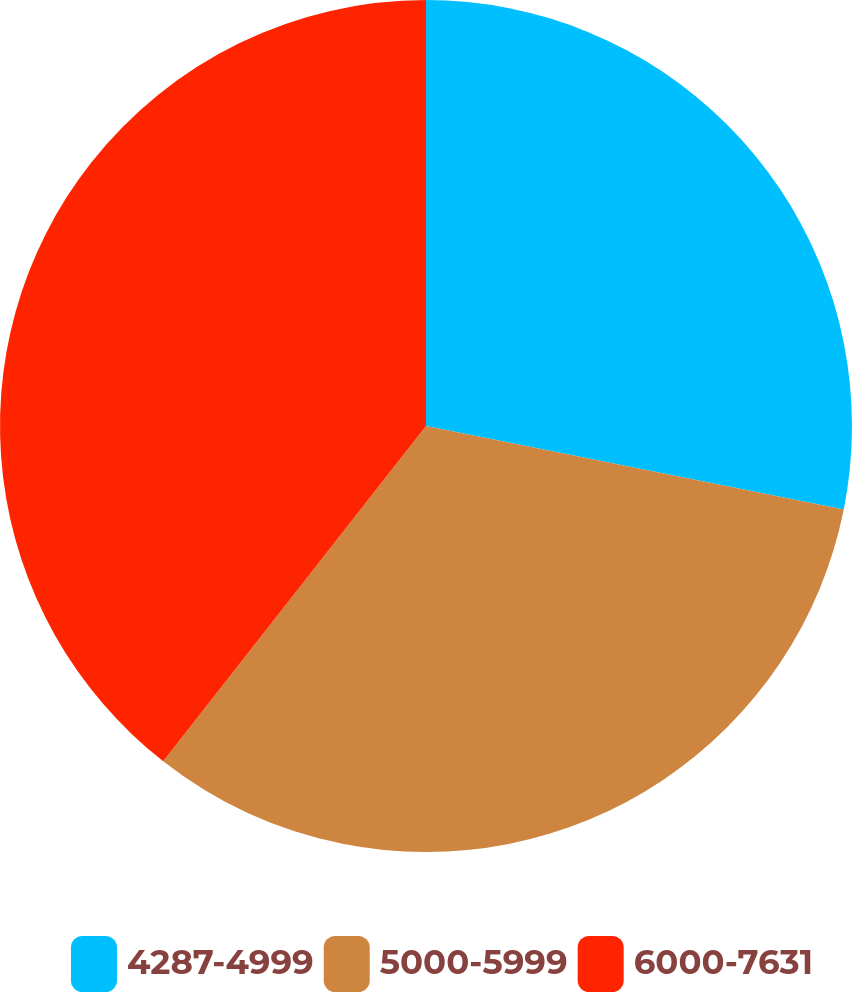Convert chart. <chart><loc_0><loc_0><loc_500><loc_500><pie_chart><fcel>4287-4999<fcel>5000-5999<fcel>6000-7631<nl><fcel>28.14%<fcel>32.44%<fcel>39.42%<nl></chart> 